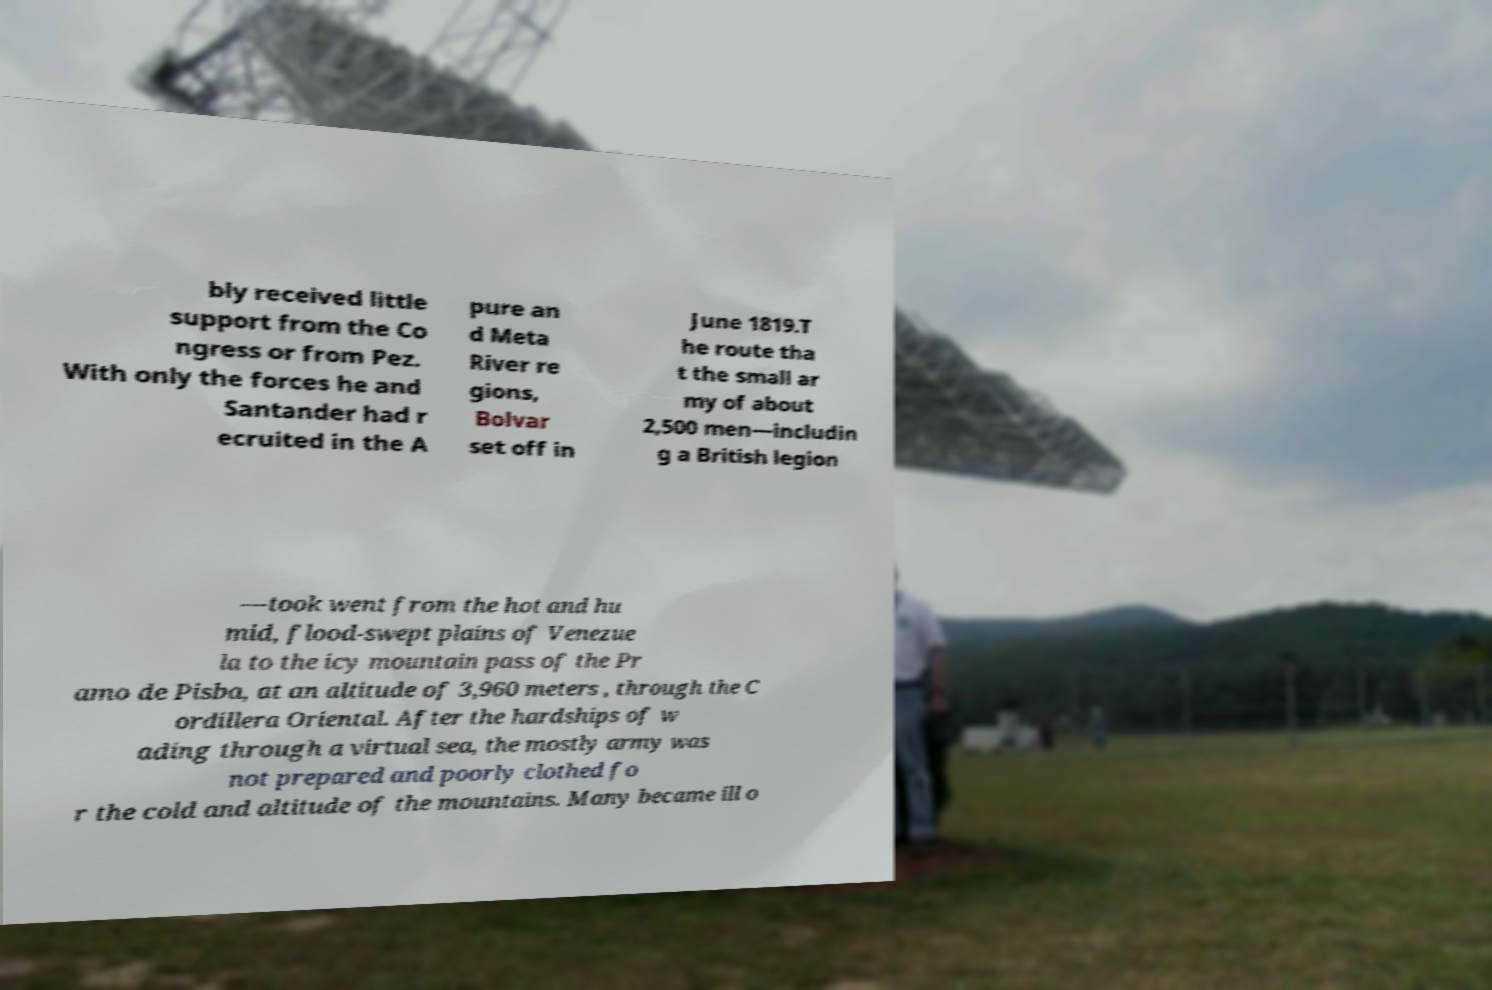For documentation purposes, I need the text within this image transcribed. Could you provide that? bly received little support from the Co ngress or from Pez. With only the forces he and Santander had r ecruited in the A pure an d Meta River re gions, Bolvar set off in June 1819.T he route tha t the small ar my of about 2,500 men—includin g a British legion —took went from the hot and hu mid, flood-swept plains of Venezue la to the icy mountain pass of the Pr amo de Pisba, at an altitude of 3,960 meters , through the C ordillera Oriental. After the hardships of w ading through a virtual sea, the mostly army was not prepared and poorly clothed fo r the cold and altitude of the mountains. Many became ill o 